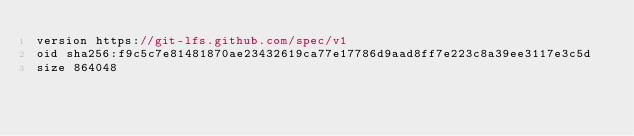<code> <loc_0><loc_0><loc_500><loc_500><_TypeScript_>version https://git-lfs.github.com/spec/v1
oid sha256:f9c5c7e81481870ae23432619ca77e17786d9aad8ff7e223c8a39ee3117e3c5d
size 864048
</code> 